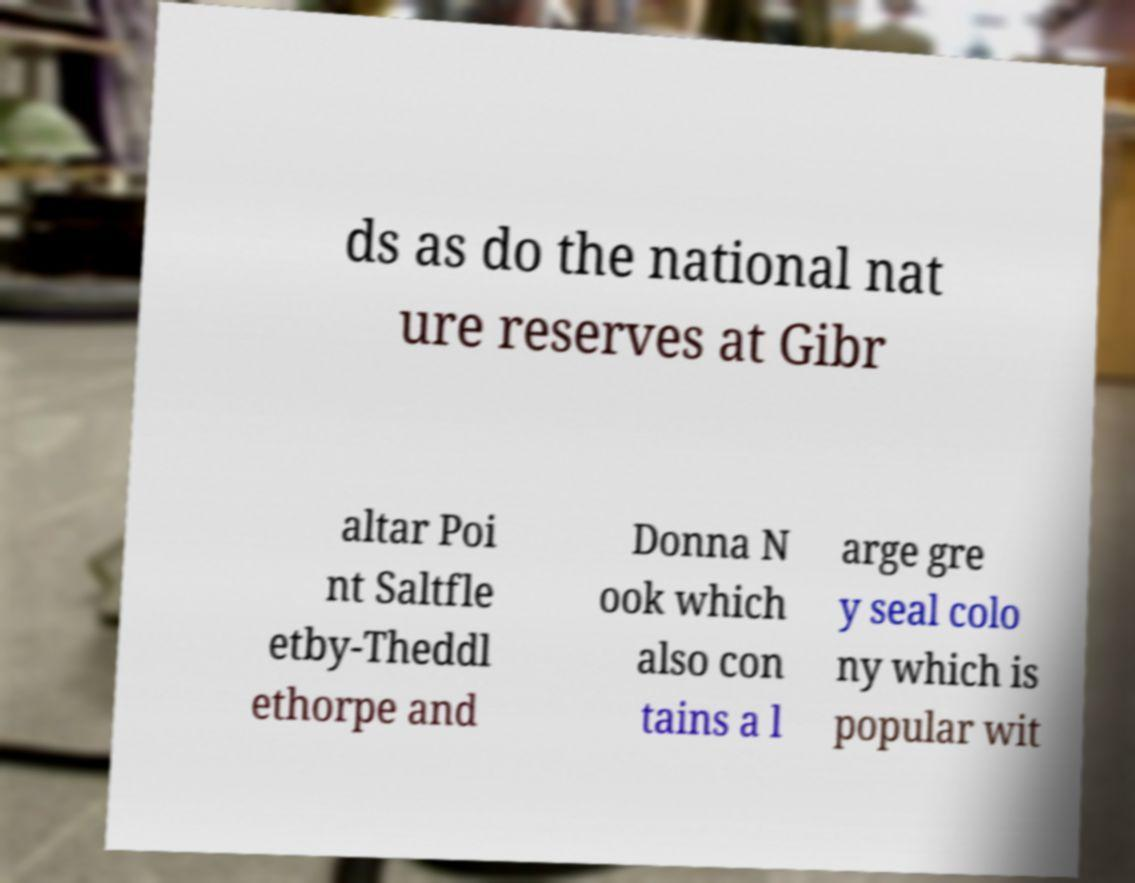Can you read and provide the text displayed in the image?This photo seems to have some interesting text. Can you extract and type it out for me? ds as do the national nat ure reserves at Gibr altar Poi nt Saltfle etby-Theddl ethorpe and Donna N ook which also con tains a l arge gre y seal colo ny which is popular wit 